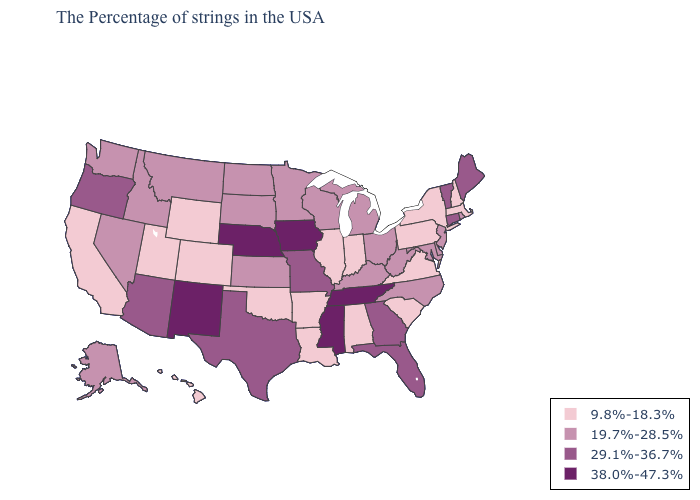Does North Dakota have the lowest value in the USA?
Write a very short answer. No. Name the states that have a value in the range 9.8%-18.3%?
Answer briefly. Massachusetts, New Hampshire, New York, Pennsylvania, Virginia, South Carolina, Indiana, Alabama, Illinois, Louisiana, Arkansas, Oklahoma, Wyoming, Colorado, Utah, California, Hawaii. Name the states that have a value in the range 29.1%-36.7%?
Be succinct. Maine, Vermont, Connecticut, Florida, Georgia, Missouri, Texas, Arizona, Oregon. What is the highest value in states that border Kentucky?
Give a very brief answer. 38.0%-47.3%. What is the value of Texas?
Short answer required. 29.1%-36.7%. Does West Virginia have the lowest value in the South?
Keep it brief. No. Name the states that have a value in the range 9.8%-18.3%?
Answer briefly. Massachusetts, New Hampshire, New York, Pennsylvania, Virginia, South Carolina, Indiana, Alabama, Illinois, Louisiana, Arkansas, Oklahoma, Wyoming, Colorado, Utah, California, Hawaii. What is the value of Florida?
Write a very short answer. 29.1%-36.7%. Name the states that have a value in the range 29.1%-36.7%?
Be succinct. Maine, Vermont, Connecticut, Florida, Georgia, Missouri, Texas, Arizona, Oregon. Among the states that border Connecticut , which have the lowest value?
Short answer required. Massachusetts, New York. Which states have the lowest value in the USA?
Keep it brief. Massachusetts, New Hampshire, New York, Pennsylvania, Virginia, South Carolina, Indiana, Alabama, Illinois, Louisiana, Arkansas, Oklahoma, Wyoming, Colorado, Utah, California, Hawaii. Which states hav the highest value in the Northeast?
Give a very brief answer. Maine, Vermont, Connecticut. What is the value of Illinois?
Short answer required. 9.8%-18.3%. Does the map have missing data?
Short answer required. No. 